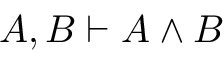<formula> <loc_0><loc_0><loc_500><loc_500>A , B \vdash A \land B</formula> 